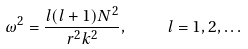<formula> <loc_0><loc_0><loc_500><loc_500>\omega ^ { 2 } = \frac { l ( l + 1 ) N ^ { 2 } } { r ^ { 2 } k ^ { 2 } } , \quad l = 1 , 2 , \dots</formula> 